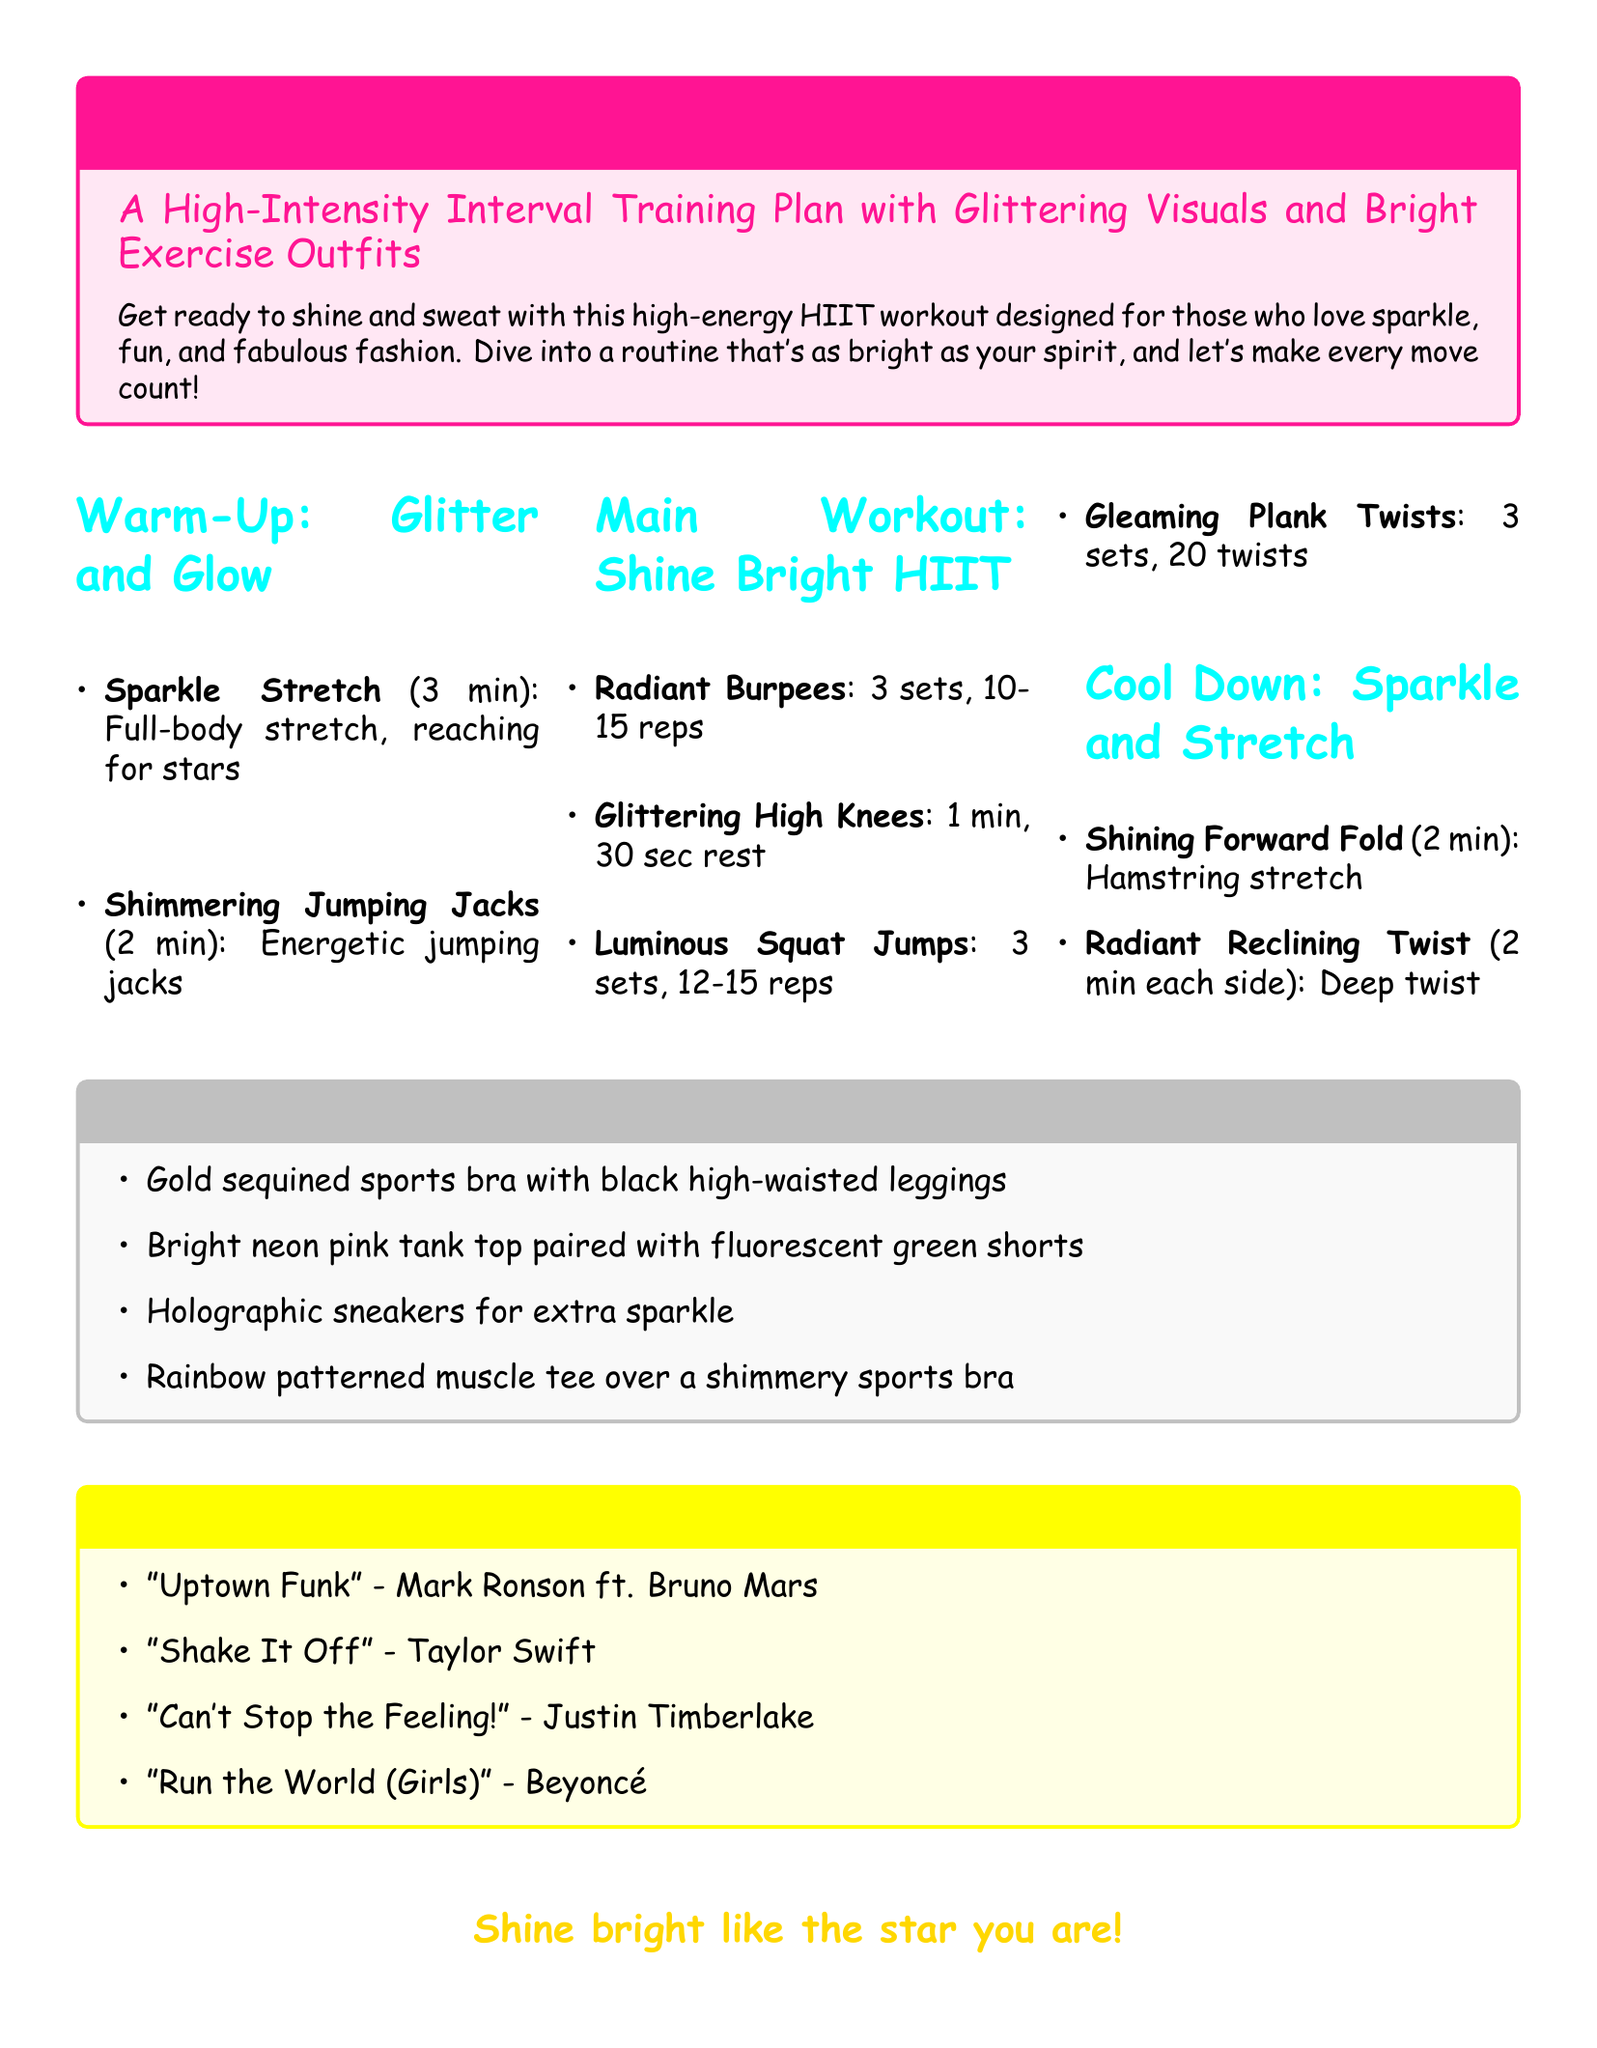What is the title of the workout plan? The title is mentioned in the document as "Sparkle-Fueled Cardio Routine."
Answer: Sparkle-Fueled Cardio Routine How long should the Sparkle Stretch last? The document specifies the duration of the Sparkle Stretch as 3 minutes.
Answer: 3 min What exercise involves jumping jacks? The item listed in the warm-up section mentions "Shimmering Jumping Jacks."
Answer: Shimmering Jumping Jacks How many sets of Radiant Burpees are included in the main workout? The document states that there are 3 sets of Radiant Burpees.
Answer: 3 sets Which song by Beyoncé is included in the music playlist? The music playlist specifically includes the song "Run the World (Girls)."
Answer: Run the World (Girls) What color are the recommended sneakers? The outfit inspiration mentions "holographic sneakers."
Answer: Holographic Which exercise is recommended for the cool down? The cool down section includes the "Shining Forward Fold" as one of the exercises.
Answer: Shining Forward Fold What type of workout is outlined in the plan? The document describes the workout as a high-intensity interval training plan (HIIT).
Answer: HIIT What color are the high-waisted leggings suggested for the outfit? The suggested outfit includes black high-waisted leggings.
Answer: Black 